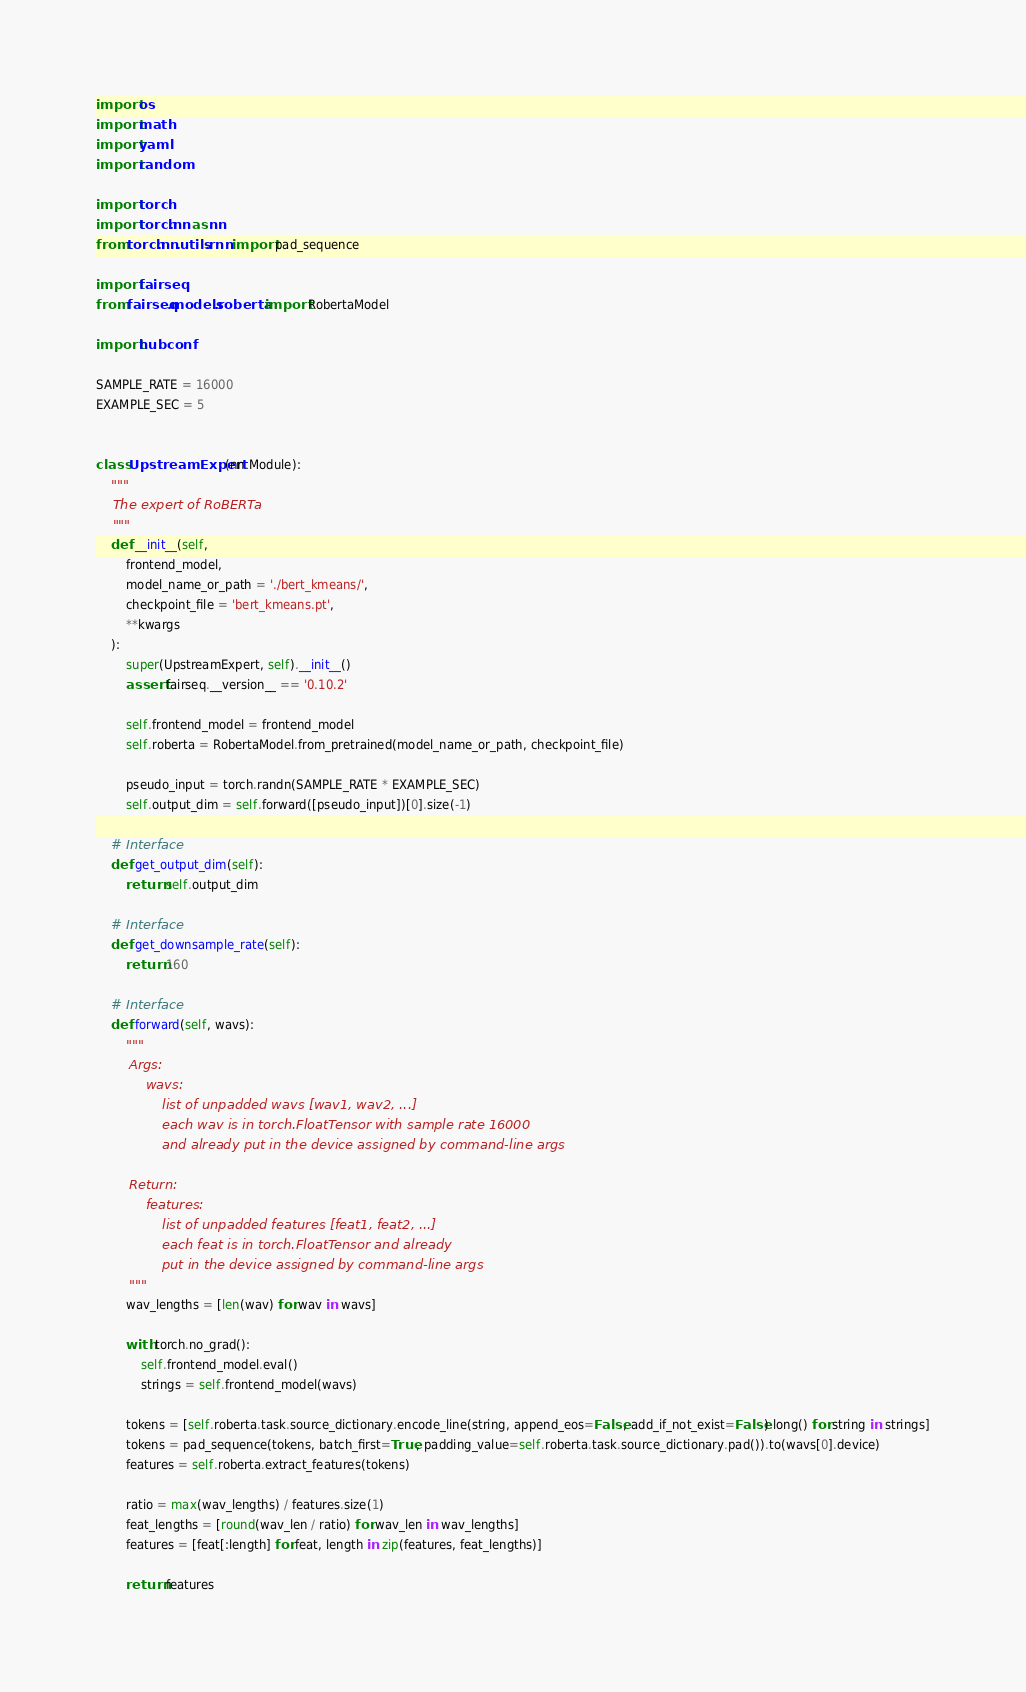<code> <loc_0><loc_0><loc_500><loc_500><_Python_>import os
import math
import yaml
import random

import torch
import torch.nn as nn
from torch.nn.utils.rnn import pad_sequence

import fairseq
from fairseq.models.roberta import RobertaModel

import hubconf

SAMPLE_RATE = 16000
EXAMPLE_SEC = 5


class UpstreamExpert(nn.Module):
    """
    The expert of RoBERTa
    """
    def __init__(self,
        frontend_model,
        model_name_or_path = './bert_kmeans/',
        checkpoint_file = 'bert_kmeans.pt',
        **kwargs
    ):
        super(UpstreamExpert, self).__init__()
        assert fairseq.__version__ == '0.10.2'

        self.frontend_model = frontend_model
        self.roberta = RobertaModel.from_pretrained(model_name_or_path, checkpoint_file)

        pseudo_input = torch.randn(SAMPLE_RATE * EXAMPLE_SEC)
        self.output_dim = self.forward([pseudo_input])[0].size(-1)

    # Interface
    def get_output_dim(self):
        return self.output_dim

    # Interface
    def get_downsample_rate(self):
        return 160

    # Interface
    def forward(self, wavs):
        """
        Args:
            wavs:
                list of unpadded wavs [wav1, wav2, ...]
                each wav is in torch.FloatTensor with sample rate 16000
                and already put in the device assigned by command-line args

        Return:
            features:
                list of unpadded features [feat1, feat2, ...]
                each feat is in torch.FloatTensor and already
                put in the device assigned by command-line args
        """
        wav_lengths = [len(wav) for wav in wavs]

        with torch.no_grad():
            self.frontend_model.eval()
            strings = self.frontend_model(wavs)

        tokens = [self.roberta.task.source_dictionary.encode_line(string, append_eos=False, add_if_not_exist=False).long() for string in strings]
        tokens = pad_sequence(tokens, batch_first=True, padding_value=self.roberta.task.source_dictionary.pad()).to(wavs[0].device)
        features = self.roberta.extract_features(tokens)
        
        ratio = max(wav_lengths) / features.size(1)
        feat_lengths = [round(wav_len / ratio) for wav_len in wav_lengths]
        features = [feat[:length] for feat, length in zip(features, feat_lengths)]

        return features
</code> 